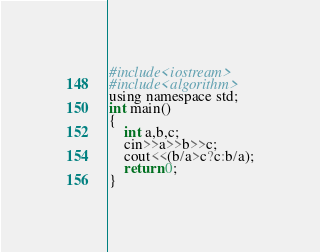Convert code to text. <code><loc_0><loc_0><loc_500><loc_500><_Awk_>#include<iostream>
#include<algorithm>
using namespace std;
int main()
{
	int a,b,c;
	cin>>a>>b>>c;
	cout<<(b/a>c?c:b/a);
	return 0;
}</code> 